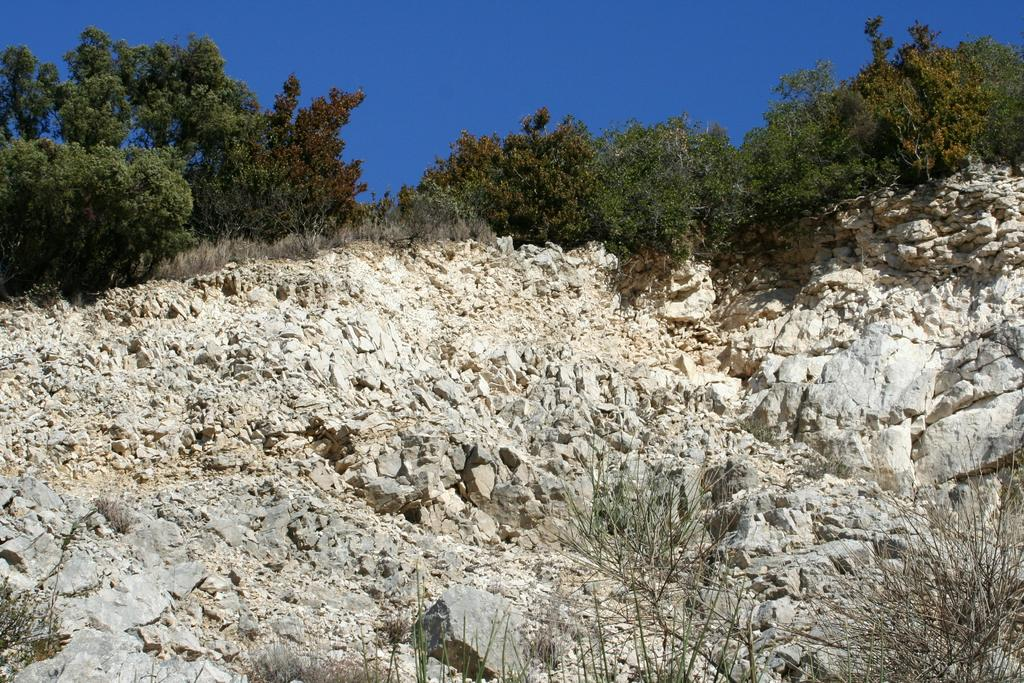What type of natural elements can be seen on the ground in the image? There are rocks on the ground in the image. What is growing on the rocks? There are plants on the rocks. What can be seen in the background of the image? There are trees in the background of the image. What is visible at the top of the image? The sky is visible at the top of the image. Can you see any magic happening in the image? There is no magic present in the image. Is there a tray visible in the image? There is no tray present in the image. 